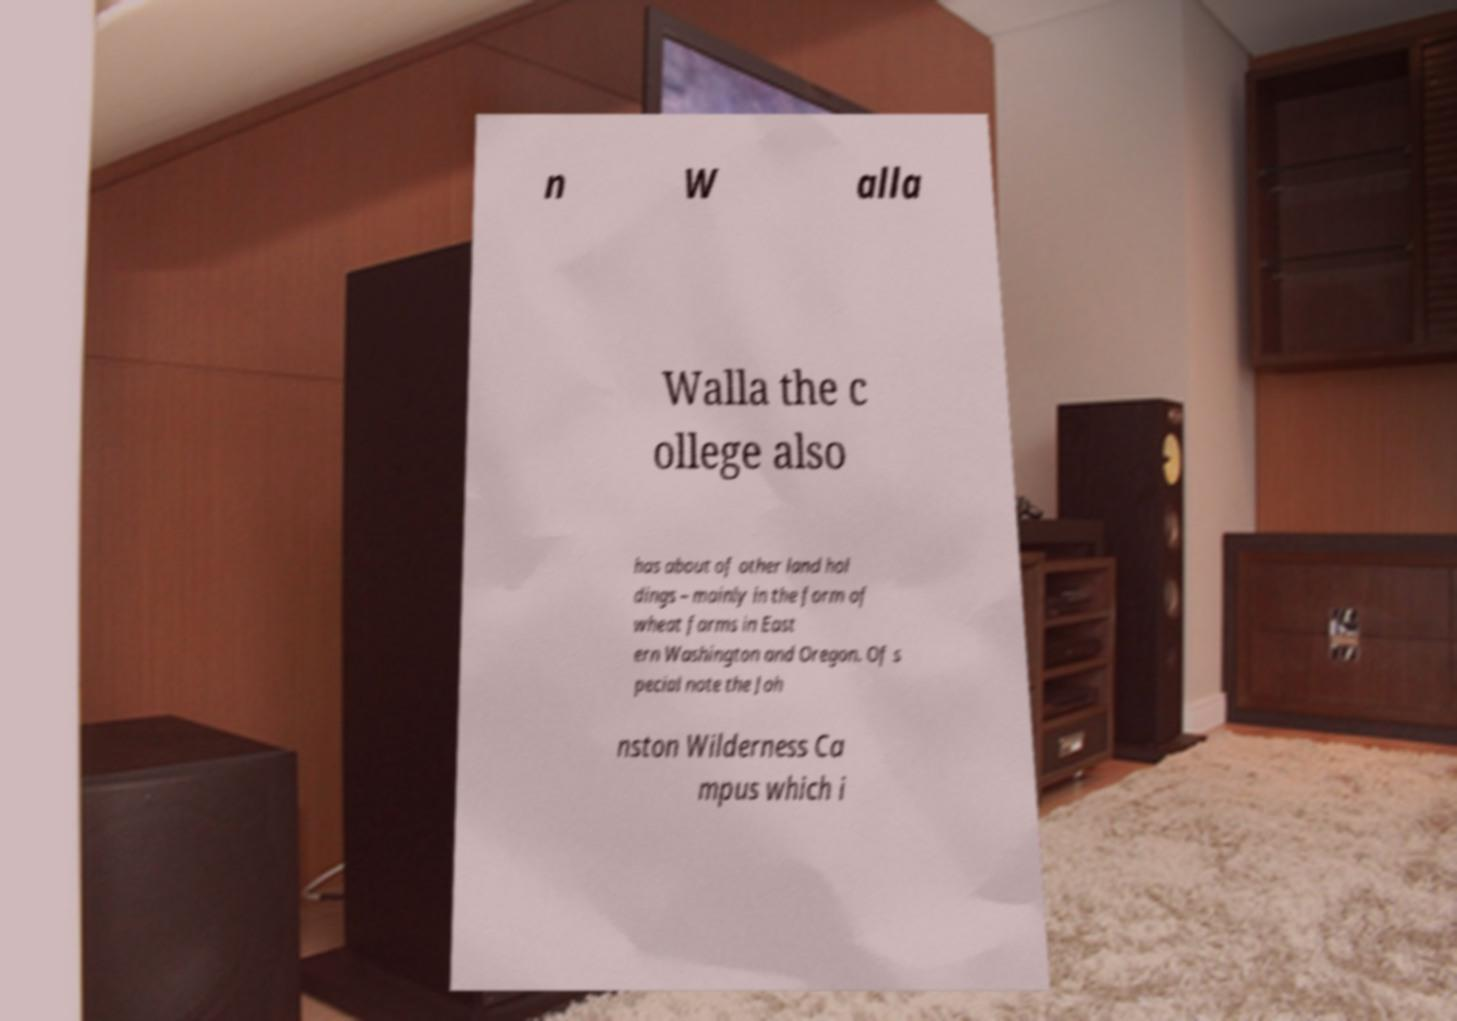What messages or text are displayed in this image? I need them in a readable, typed format. n W alla Walla the c ollege also has about of other land hol dings – mainly in the form of wheat farms in East ern Washington and Oregon. Of s pecial note the Joh nston Wilderness Ca mpus which i 